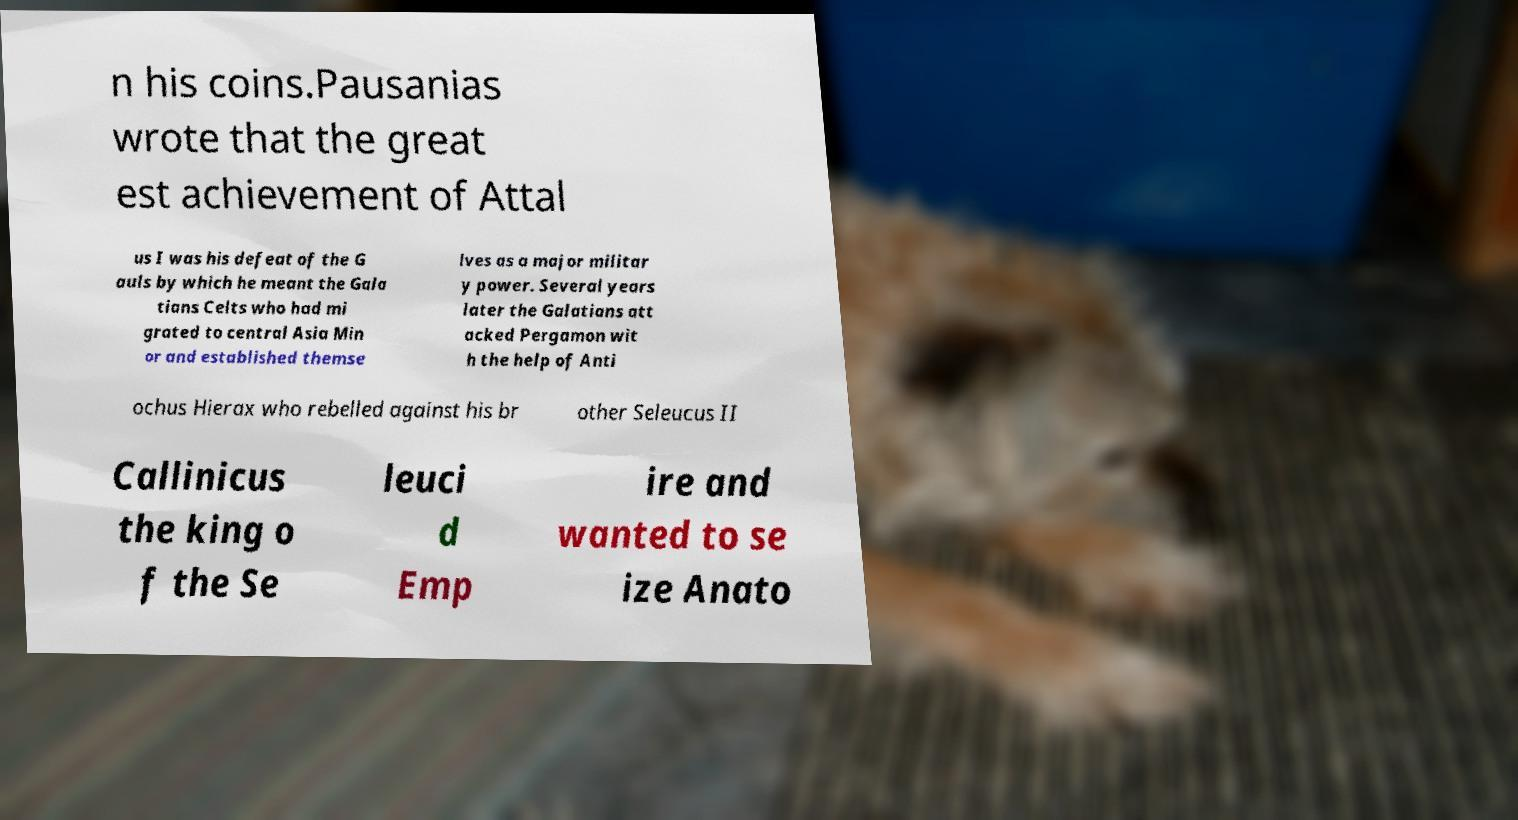Can you accurately transcribe the text from the provided image for me? n his coins.Pausanias wrote that the great est achievement of Attal us I was his defeat of the G auls by which he meant the Gala tians Celts who had mi grated to central Asia Min or and established themse lves as a major militar y power. Several years later the Galatians att acked Pergamon wit h the help of Anti ochus Hierax who rebelled against his br other Seleucus II Callinicus the king o f the Se leuci d Emp ire and wanted to se ize Anato 